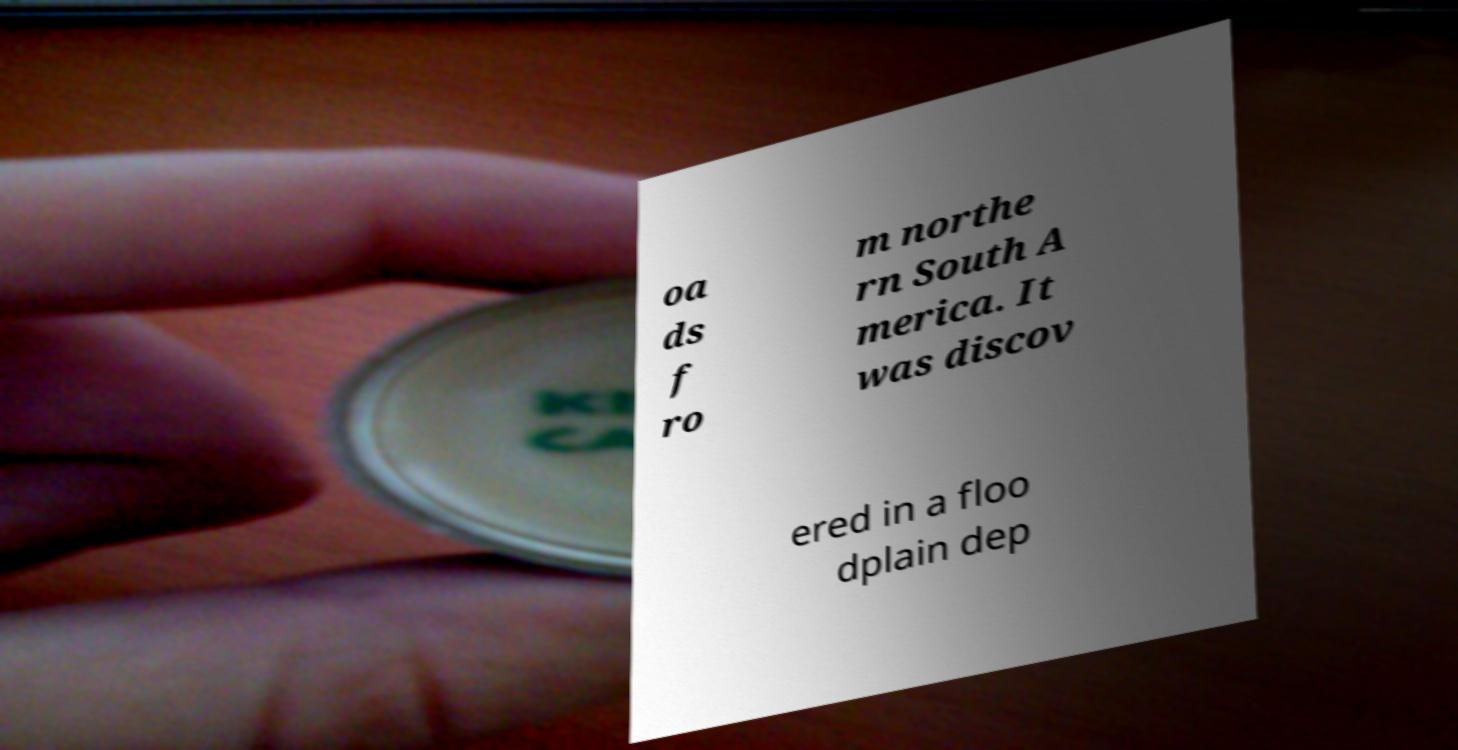Can you read and provide the text displayed in the image?This photo seems to have some interesting text. Can you extract and type it out for me? oa ds f ro m northe rn South A merica. It was discov ered in a floo dplain dep 